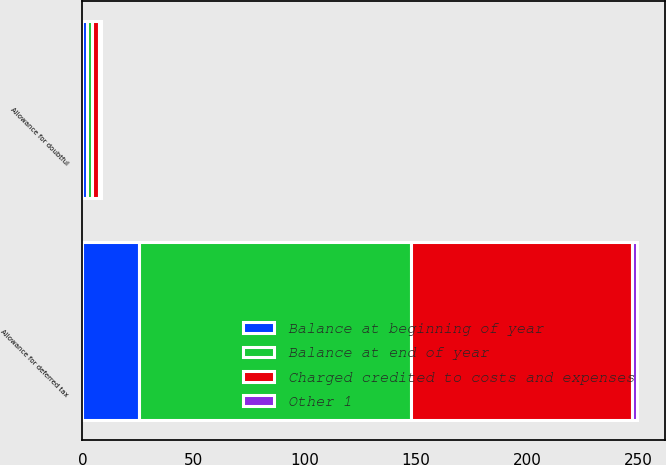Convert chart to OTSL. <chart><loc_0><loc_0><loc_500><loc_500><stacked_bar_chart><ecel><fcel>Allowance for doubtful<fcel>Allowance for deferred tax<nl><fcel>Charged credited to costs and expenses<fcel>3.5<fcel>99.2<nl><fcel>Other 1<fcel>0.6<fcel>2.4<nl><fcel>Balance at beginning of year<fcel>1.9<fcel>25.5<nl><fcel>Balance at end of year<fcel>2.2<fcel>122.3<nl></chart> 